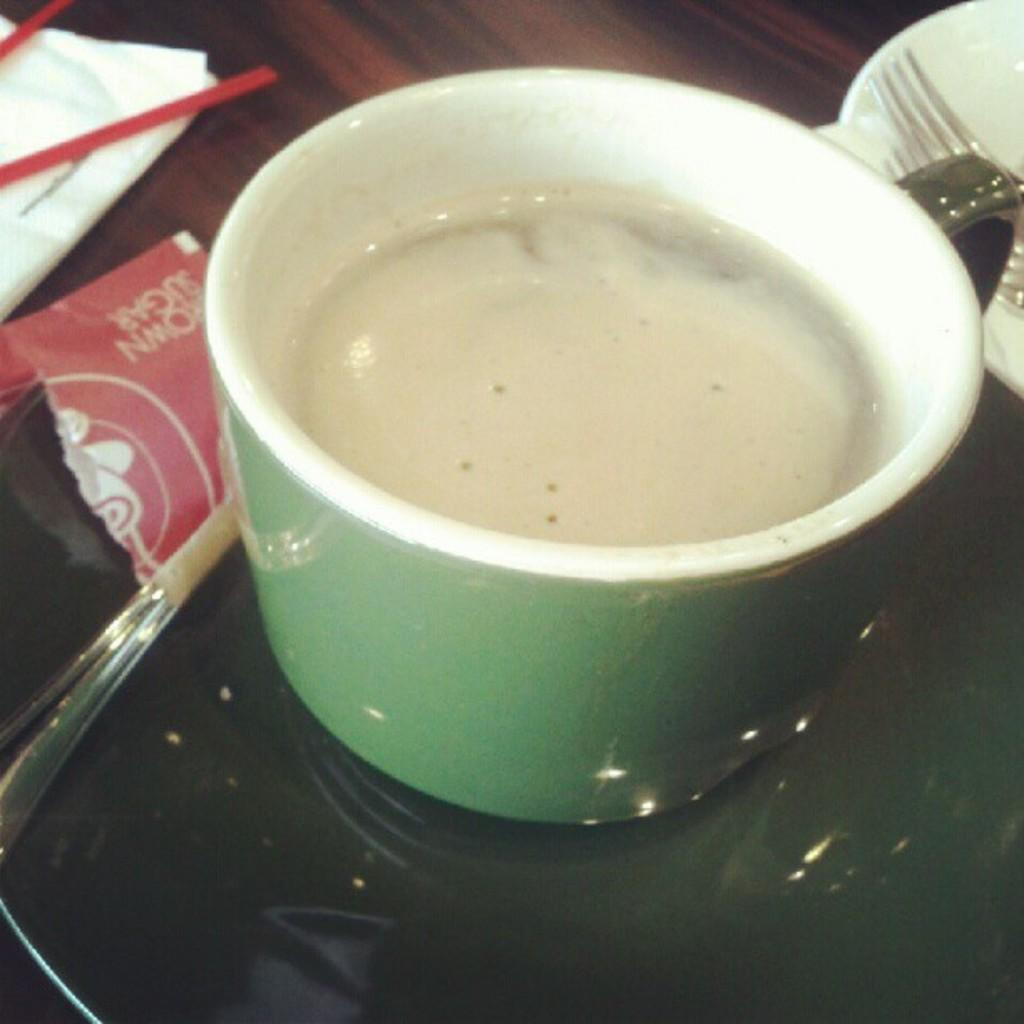What piece of furniture is present in the image? There is a table in the image. What is on the table? There is a cup on the table, and the cup contains liquid. Is there anything else on the table besides the cup? Yes, there is a plate next to the cup. What is on the plate? There are objects on the plate. Can you tell me how many dogs are sitting on the plate in the image? There are no dogs present in the image; the plate contains objects, not animals. 